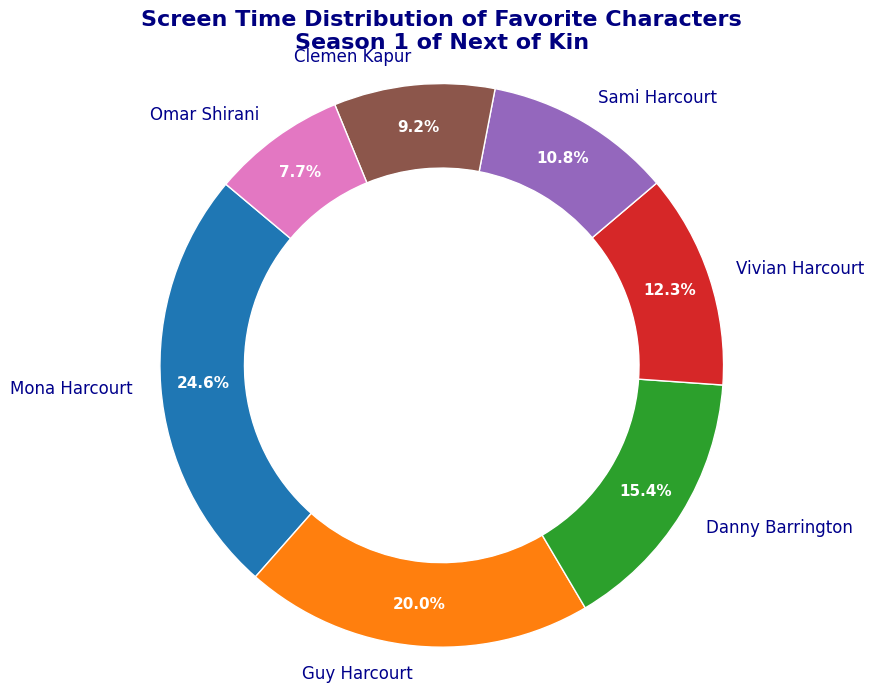What is the total screen time of Mona Harcourt and Guy Harcourt? Mona Harcourt's screen time is 80 minutes and Guy Harcourt's is 65 minutes. Adding them together: 80 + 65 = 145 minutes.
Answer: 145 minutes Which character has more screen time, Danny Barrington or Vivian Harcourt? Danny Barrington's screen time is 50 minutes, while Vivian Harcourt's is 40 minutes. Since 50 is greater than 40, Danny Barrington has more screen time.
Answer: Danny Barrington Who has the least screen time among the characters? When we look at the screen times: Mona Harcourt (80), Guy Harcourt (65), Danny Barrington (50), Vivian Harcourt (40), Sami Harcourt (35), Clemen Kapur (30), Omar Shirani (25), we see that Omar Shirani has the least screen time with 25 minutes.
Answer: Omar Shirani What percentage of the total screen time is occupied by Mona Harcourt and Sami Harcourt combined? First, add their screen times: 80 (Mona Harcourt) + 35 (Sami Harcourt) = 115 minutes. Next, calculate the total screen time of all characters: 80 + 65 + 50 + 40 + 35 + 30 + 25 = 325 minutes. The percentage is then (115 / 325) * 100 ≈ 35.4%.
Answer: 35.4% Compare the screen time of Guy Harcourt and Clemen Kapur. How much more screen time does Guy Harcourt have compared to Clemen Kapur? Guy Harcourt has 65 minutes of screen time, and Clemen Kapur has 30 minutes. Subtracting their screen times gives: 65 - 30 = 35 minutes.
Answer: 35 minutes What is the difference in screen time between the character with the most screen time and the character with the least screen time? Mona Harcourt has the most screen time (80 minutes), and Omar Shirani has the least (25 minutes). The difference is 80 - 25 = 55 minutes.
Answer: 55 minutes How does the screen time of Sami Harcourt compare to Vivian Harcourt? Sami Harcourt has 35 minutes of screen time, while Vivian Harcourt has 40 minutes. Since 35 is less than 40, Sami Harcourt has less screen time than Vivian Harcourt.
Answer: Less screen time What is the average screen time of all characters? First, calculate the total screen time: 80 + 65 + 50 + 40 + 35 + 30 + 25 = 325 minutes. There are 7 characters, so the average screen time is 325 / 7 ≈ 46.4 minutes.
Answer: 46.4 minutes By how many minutes does Danny Barrington's screen time exceed the screen time of Omar Shirani? Danny Barrington's screen time is 50 minutes and Omar Shirani's is 25 minutes. The difference is 50 - 25 = 25 minutes.
Answer: 25 minutes 